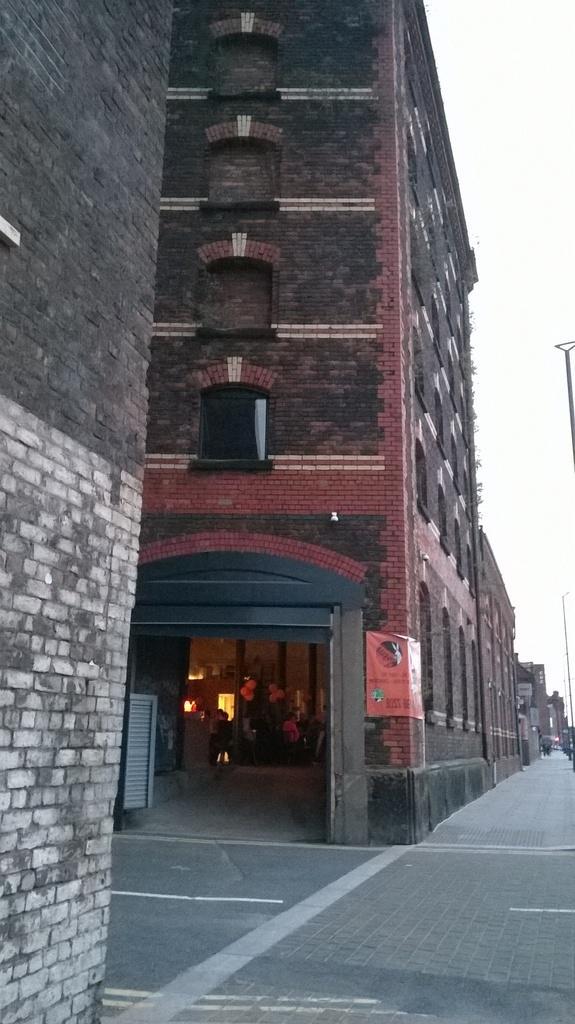Can you describe this image briefly? In this picture I can see many buildings. In the center I can see the balloons, pillar, lights, chairs, tables and other objects through the door. On the right I can see the street lights and poles. In the top right I can see the sky. 